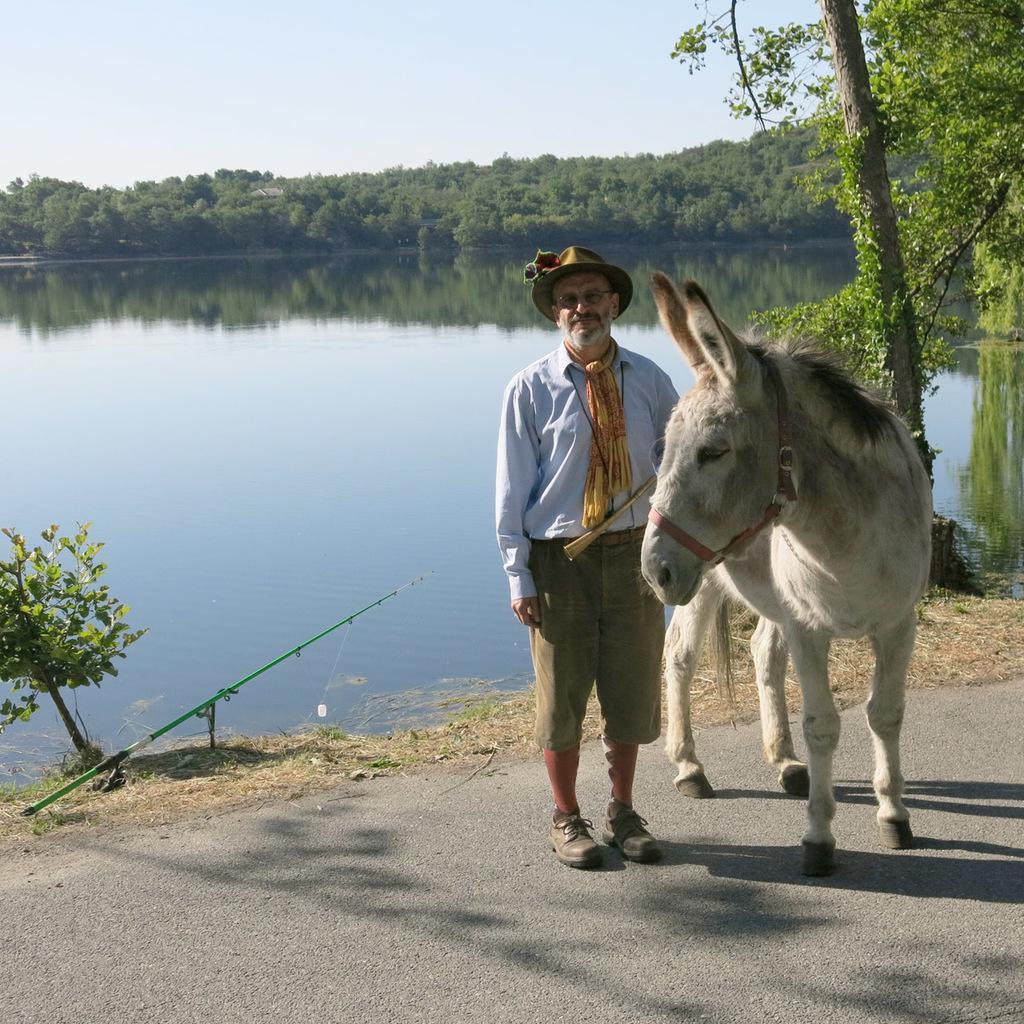Could you give a brief overview of what you see in this image? In this picture we can see a horse and a man standing on the road, fishing rod, water, trees and this man wore a cap, spectacle and shoes and in the background we can see the sky. 